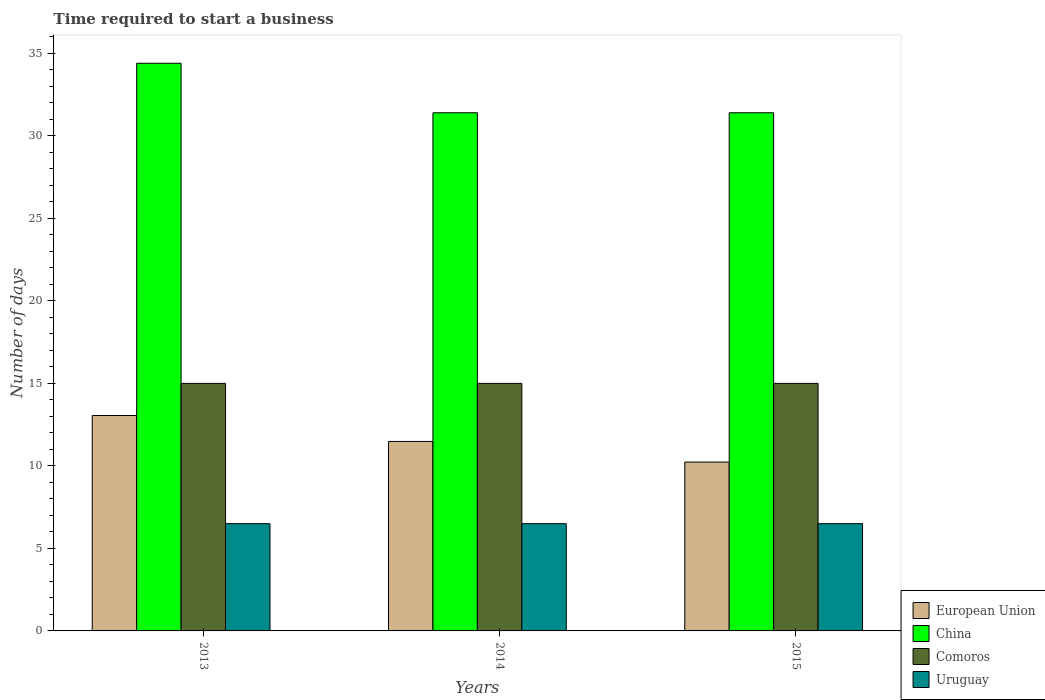How many groups of bars are there?
Give a very brief answer. 3. Are the number of bars per tick equal to the number of legend labels?
Your response must be concise. Yes. Are the number of bars on each tick of the X-axis equal?
Your answer should be very brief. Yes. What is the label of the 3rd group of bars from the left?
Offer a very short reply. 2015. In how many cases, is the number of bars for a given year not equal to the number of legend labels?
Your answer should be compact. 0. Across all years, what is the minimum number of days required to start a business in Comoros?
Give a very brief answer. 15. In which year was the number of days required to start a business in European Union minimum?
Give a very brief answer. 2015. What is the total number of days required to start a business in European Union in the graph?
Keep it short and to the point. 34.77. What is the difference between the number of days required to start a business in China in 2014 and that in 2015?
Offer a very short reply. 0. What is the average number of days required to start a business in European Union per year?
Provide a short and direct response. 11.59. In the year 2015, what is the difference between the number of days required to start a business in Comoros and number of days required to start a business in European Union?
Keep it short and to the point. 4.77. In how many years, is the number of days required to start a business in European Union greater than 1 days?
Provide a succinct answer. 3. What is the ratio of the number of days required to start a business in Comoros in 2013 to that in 2015?
Make the answer very short. 1. What is the difference between the highest and the lowest number of days required to start a business in China?
Your answer should be compact. 3. Is it the case that in every year, the sum of the number of days required to start a business in Uruguay and number of days required to start a business in China is greater than the sum of number of days required to start a business in Comoros and number of days required to start a business in European Union?
Ensure brevity in your answer.  Yes. What does the 1st bar from the left in 2013 represents?
Give a very brief answer. European Union. What does the 1st bar from the right in 2013 represents?
Your answer should be compact. Uruguay. How many bars are there?
Your response must be concise. 12. Are all the bars in the graph horizontal?
Provide a short and direct response. No. How many years are there in the graph?
Your answer should be compact. 3. Does the graph contain any zero values?
Make the answer very short. No. How many legend labels are there?
Offer a very short reply. 4. How are the legend labels stacked?
Offer a very short reply. Vertical. What is the title of the graph?
Offer a terse response. Time required to start a business. What is the label or title of the Y-axis?
Your answer should be very brief. Number of days. What is the Number of days of European Union in 2013?
Your response must be concise. 13.05. What is the Number of days in China in 2013?
Provide a short and direct response. 34.4. What is the Number of days of Comoros in 2013?
Make the answer very short. 15. What is the Number of days of Uruguay in 2013?
Your response must be concise. 6.5. What is the Number of days in European Union in 2014?
Offer a very short reply. 11.48. What is the Number of days of China in 2014?
Keep it short and to the point. 31.4. What is the Number of days in Comoros in 2014?
Keep it short and to the point. 15. What is the Number of days in Uruguay in 2014?
Offer a very short reply. 6.5. What is the Number of days of European Union in 2015?
Make the answer very short. 10.23. What is the Number of days of China in 2015?
Keep it short and to the point. 31.4. What is the Number of days of Comoros in 2015?
Provide a short and direct response. 15. What is the Number of days of Uruguay in 2015?
Give a very brief answer. 6.5. Across all years, what is the maximum Number of days of European Union?
Provide a succinct answer. 13.05. Across all years, what is the maximum Number of days in China?
Keep it short and to the point. 34.4. Across all years, what is the maximum Number of days of Comoros?
Ensure brevity in your answer.  15. Across all years, what is the maximum Number of days in Uruguay?
Give a very brief answer. 6.5. Across all years, what is the minimum Number of days of European Union?
Provide a succinct answer. 10.23. Across all years, what is the minimum Number of days of China?
Your answer should be very brief. 31.4. What is the total Number of days of European Union in the graph?
Your response must be concise. 34.77. What is the total Number of days of China in the graph?
Your answer should be compact. 97.2. What is the total Number of days in Uruguay in the graph?
Your answer should be very brief. 19.5. What is the difference between the Number of days in European Union in 2013 and that in 2014?
Provide a short and direct response. 1.57. What is the difference between the Number of days in China in 2013 and that in 2014?
Offer a terse response. 3. What is the difference between the Number of days of Comoros in 2013 and that in 2014?
Offer a very short reply. 0. What is the difference between the Number of days of Uruguay in 2013 and that in 2014?
Offer a terse response. 0. What is the difference between the Number of days in European Union in 2013 and that in 2015?
Ensure brevity in your answer.  2.82. What is the difference between the Number of days in European Union in 2014 and that in 2015?
Provide a succinct answer. 1.25. What is the difference between the Number of days in China in 2014 and that in 2015?
Provide a short and direct response. 0. What is the difference between the Number of days in European Union in 2013 and the Number of days in China in 2014?
Give a very brief answer. -18.35. What is the difference between the Number of days of European Union in 2013 and the Number of days of Comoros in 2014?
Make the answer very short. -1.95. What is the difference between the Number of days of European Union in 2013 and the Number of days of Uruguay in 2014?
Offer a terse response. 6.55. What is the difference between the Number of days of China in 2013 and the Number of days of Comoros in 2014?
Your answer should be compact. 19.4. What is the difference between the Number of days of China in 2013 and the Number of days of Uruguay in 2014?
Offer a terse response. 27.9. What is the difference between the Number of days in European Union in 2013 and the Number of days in China in 2015?
Your answer should be very brief. -18.35. What is the difference between the Number of days in European Union in 2013 and the Number of days in Comoros in 2015?
Your answer should be very brief. -1.95. What is the difference between the Number of days of European Union in 2013 and the Number of days of Uruguay in 2015?
Your answer should be compact. 6.55. What is the difference between the Number of days of China in 2013 and the Number of days of Comoros in 2015?
Ensure brevity in your answer.  19.4. What is the difference between the Number of days in China in 2013 and the Number of days in Uruguay in 2015?
Your response must be concise. 27.9. What is the difference between the Number of days of Comoros in 2013 and the Number of days of Uruguay in 2015?
Your answer should be compact. 8.5. What is the difference between the Number of days in European Union in 2014 and the Number of days in China in 2015?
Make the answer very short. -19.92. What is the difference between the Number of days in European Union in 2014 and the Number of days in Comoros in 2015?
Provide a succinct answer. -3.52. What is the difference between the Number of days in European Union in 2014 and the Number of days in Uruguay in 2015?
Ensure brevity in your answer.  4.98. What is the difference between the Number of days in China in 2014 and the Number of days in Uruguay in 2015?
Your answer should be compact. 24.9. What is the average Number of days of European Union per year?
Offer a very short reply. 11.59. What is the average Number of days of China per year?
Provide a succinct answer. 32.4. What is the average Number of days in Uruguay per year?
Ensure brevity in your answer.  6.5. In the year 2013, what is the difference between the Number of days in European Union and Number of days in China?
Provide a succinct answer. -21.35. In the year 2013, what is the difference between the Number of days in European Union and Number of days in Comoros?
Your answer should be compact. -1.95. In the year 2013, what is the difference between the Number of days of European Union and Number of days of Uruguay?
Offer a terse response. 6.55. In the year 2013, what is the difference between the Number of days of China and Number of days of Comoros?
Provide a succinct answer. 19.4. In the year 2013, what is the difference between the Number of days of China and Number of days of Uruguay?
Offer a terse response. 27.9. In the year 2014, what is the difference between the Number of days of European Union and Number of days of China?
Ensure brevity in your answer.  -19.92. In the year 2014, what is the difference between the Number of days in European Union and Number of days in Comoros?
Your answer should be compact. -3.52. In the year 2014, what is the difference between the Number of days in European Union and Number of days in Uruguay?
Ensure brevity in your answer.  4.98. In the year 2014, what is the difference between the Number of days of China and Number of days of Comoros?
Your answer should be compact. 16.4. In the year 2014, what is the difference between the Number of days in China and Number of days in Uruguay?
Your answer should be very brief. 24.9. In the year 2015, what is the difference between the Number of days of European Union and Number of days of China?
Give a very brief answer. -21.17. In the year 2015, what is the difference between the Number of days of European Union and Number of days of Comoros?
Provide a short and direct response. -4.77. In the year 2015, what is the difference between the Number of days of European Union and Number of days of Uruguay?
Make the answer very short. 3.73. In the year 2015, what is the difference between the Number of days of China and Number of days of Uruguay?
Your answer should be very brief. 24.9. What is the ratio of the Number of days in European Union in 2013 to that in 2014?
Offer a very short reply. 1.14. What is the ratio of the Number of days of China in 2013 to that in 2014?
Your answer should be very brief. 1.1. What is the ratio of the Number of days of Uruguay in 2013 to that in 2014?
Your response must be concise. 1. What is the ratio of the Number of days in European Union in 2013 to that in 2015?
Keep it short and to the point. 1.28. What is the ratio of the Number of days of China in 2013 to that in 2015?
Offer a very short reply. 1.1. What is the ratio of the Number of days of Uruguay in 2013 to that in 2015?
Your answer should be very brief. 1. What is the ratio of the Number of days of European Union in 2014 to that in 2015?
Your answer should be compact. 1.12. What is the ratio of the Number of days in China in 2014 to that in 2015?
Offer a very short reply. 1. What is the ratio of the Number of days in Comoros in 2014 to that in 2015?
Your answer should be very brief. 1. What is the difference between the highest and the second highest Number of days of European Union?
Keep it short and to the point. 1.57. What is the difference between the highest and the second highest Number of days of Uruguay?
Provide a short and direct response. 0. What is the difference between the highest and the lowest Number of days of European Union?
Your answer should be compact. 2.82. What is the difference between the highest and the lowest Number of days of China?
Your response must be concise. 3. What is the difference between the highest and the lowest Number of days in Comoros?
Your answer should be compact. 0. What is the difference between the highest and the lowest Number of days in Uruguay?
Provide a short and direct response. 0. 